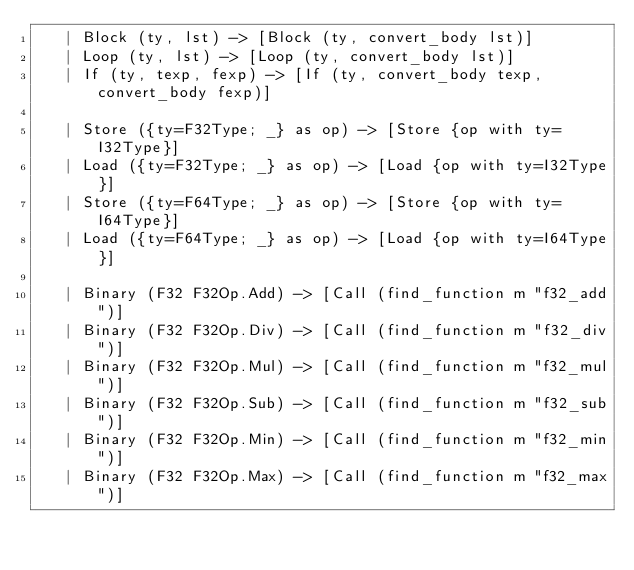<code> <loc_0><loc_0><loc_500><loc_500><_OCaml_>   | Block (ty, lst) -> [Block (ty, convert_body lst)]
   | Loop (ty, lst) -> [Loop (ty, convert_body lst)]
   | If (ty, texp, fexp) -> [If (ty, convert_body texp, convert_body fexp)]

   | Store ({ty=F32Type; _} as op) -> [Store {op with ty=I32Type}]
   | Load ({ty=F32Type; _} as op) -> [Load {op with ty=I32Type}]
   | Store ({ty=F64Type; _} as op) -> [Store {op with ty=I64Type}]
   | Load ({ty=F64Type; _} as op) -> [Load {op with ty=I64Type}]

   | Binary (F32 F32Op.Add) -> [Call (find_function m "f32_add")]
   | Binary (F32 F32Op.Div) -> [Call (find_function m "f32_div")]
   | Binary (F32 F32Op.Mul) -> [Call (find_function m "f32_mul")]
   | Binary (F32 F32Op.Sub) -> [Call (find_function m "f32_sub")]
   | Binary (F32 F32Op.Min) -> [Call (find_function m "f32_min")]
   | Binary (F32 F32Op.Max) -> [Call (find_function m "f32_max")]</code> 